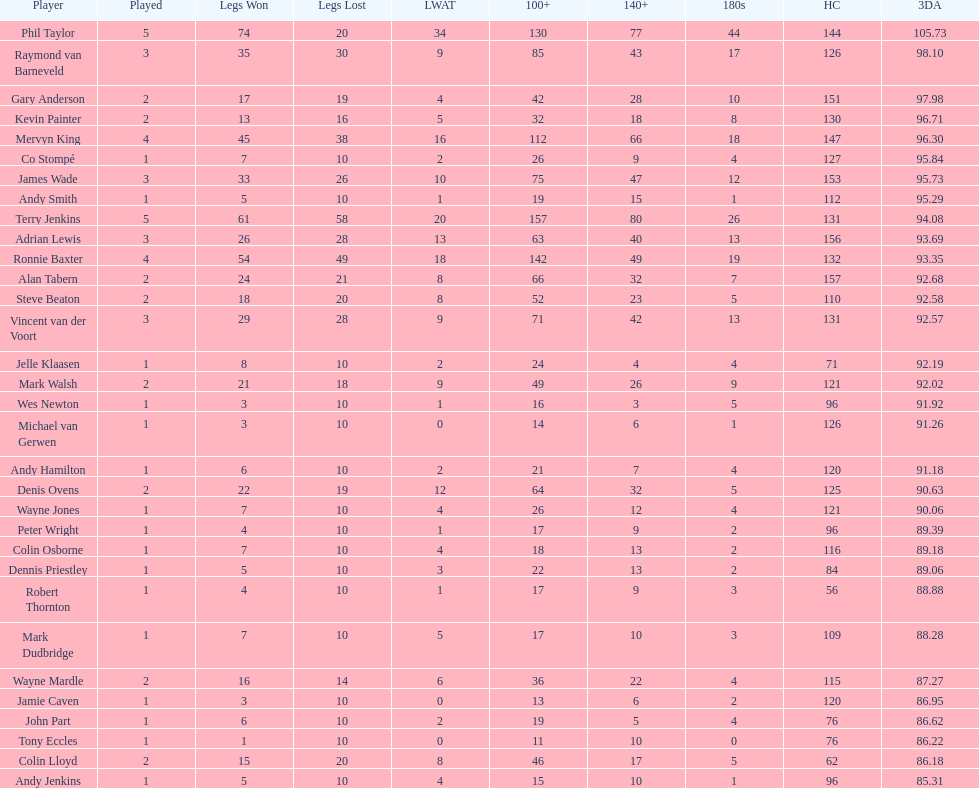What is the total amount of players who played more than 3 games? 4. 